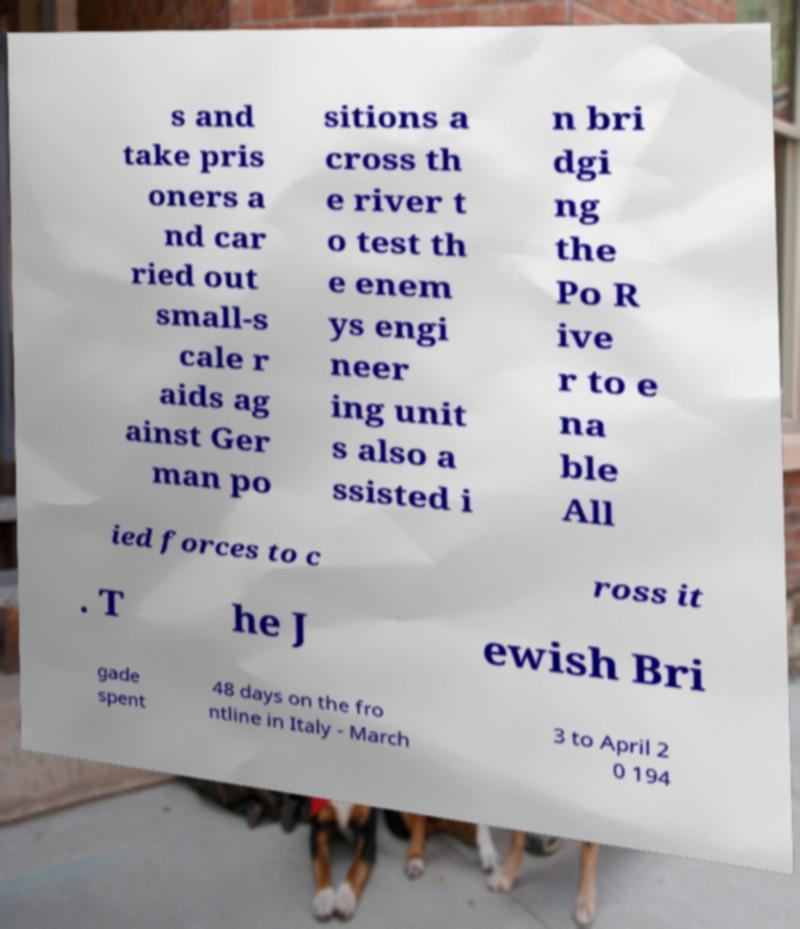Can you accurately transcribe the text from the provided image for me? s and take pris oners a nd car ried out small-s cale r aids ag ainst Ger man po sitions a cross th e river t o test th e enem ys engi neer ing unit s also a ssisted i n bri dgi ng the Po R ive r to e na ble All ied forces to c ross it . T he J ewish Bri gade spent 48 days on the fro ntline in Italy - March 3 to April 2 0 194 